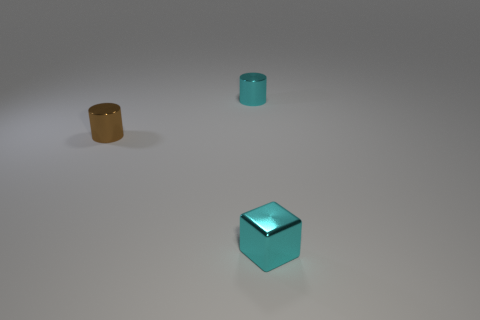What shape is the brown metallic object that is the same size as the metal cube?
Keep it short and to the point. Cylinder. There is a cyan metallic cylinder; are there any shiny cylinders right of it?
Offer a very short reply. No. Does the small cyan thing left of the tiny cyan block have the same material as the cyan block that is in front of the cyan shiny cylinder?
Your answer should be compact. Yes. How many cyan metal objects have the same size as the cyan block?
Give a very brief answer. 1. There is a metallic thing that is the same color as the block; what shape is it?
Ensure brevity in your answer.  Cylinder. There is a cyan thing that is in front of the cyan shiny cylinder; what material is it?
Offer a very short reply. Metal. How many other brown things are the same shape as the small brown metallic object?
Your answer should be very brief. 0. There is a cyan object that is made of the same material as the block; what is its shape?
Make the answer very short. Cylinder. What shape is the cyan shiny thing that is behind the tiny block right of the cyan shiny object behind the block?
Give a very brief answer. Cylinder. Is the number of tiny brown cylinders greater than the number of tiny cyan objects?
Your answer should be compact. No. 